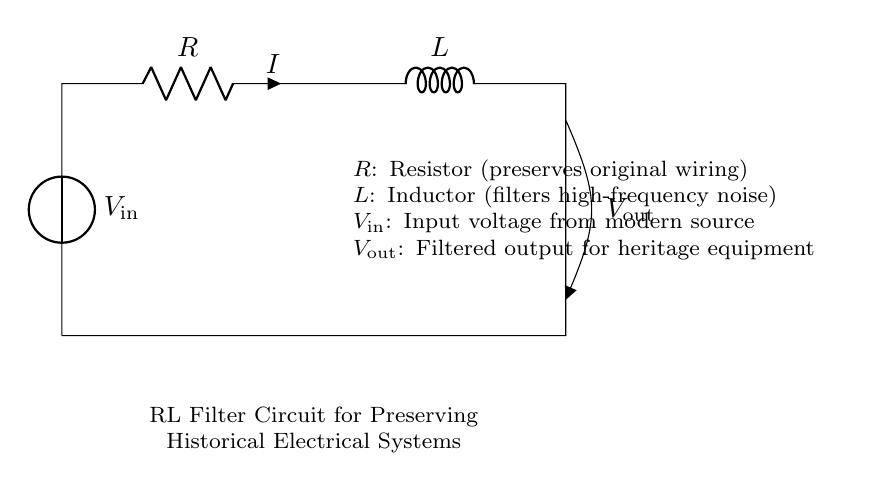What is the input voltage in this circuit? The input voltage is labeled as \( V_\text{in} \) in the diagram, indicating the voltage supplied to the circuit from a modern source.
Answer: \( V_\text{in} \) What component is used to filter high-frequency noise? The inductor \( L \) is the component designed to filter high-frequency noise in the circuit, as inductors naturally oppose changes in current and are effective at blocking high-frequency signals.
Answer: \( L \) What is the role of the resistor in this circuit? The resistor \( R \) is used to preserve the original wiring of the electrical system. This means it helps maintain the integrity of the existing historical electrical system by diminishing the impact of any modern electrical modifications.
Answer: \( R \) What is the output of this filter circuit? The output is labeled as \( V_\text{out} \), which is the filtered voltage signal that is provided to heritage equipment after the noise reduction by the RL filter.
Answer: \( V_\text{out} \) What type of circuit is represented here? This is a resistor-inductor (RL) filter circuit, characterized by the combination of a resistor and an inductor connected in series to filter the input signal.
Answer: RL filter circuit How does the value of inductance affect the filter's performance? A higher inductance value increases the impedance to high-frequency signals more effectively, which results in better filtering of unwanted high-frequency noise while allowing lower frequencies to pass through more easily.
Answer: Higher inductance What does \( I \) represent in this circuit? \( I \) represents the current flowing through the circuit, which is indicated in the diagram as the variable associated with the resistor.
Answer: \( I \) 